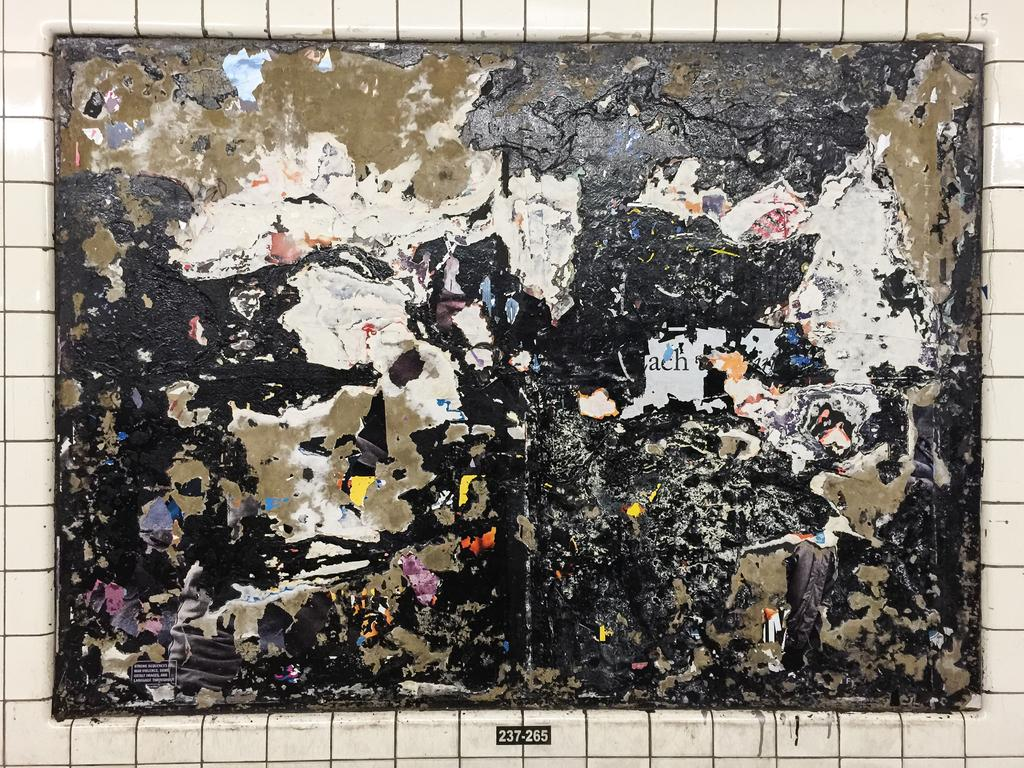<image>
Provide a brief description of the given image. A painting with the numbers 237-265 at the bottom. 